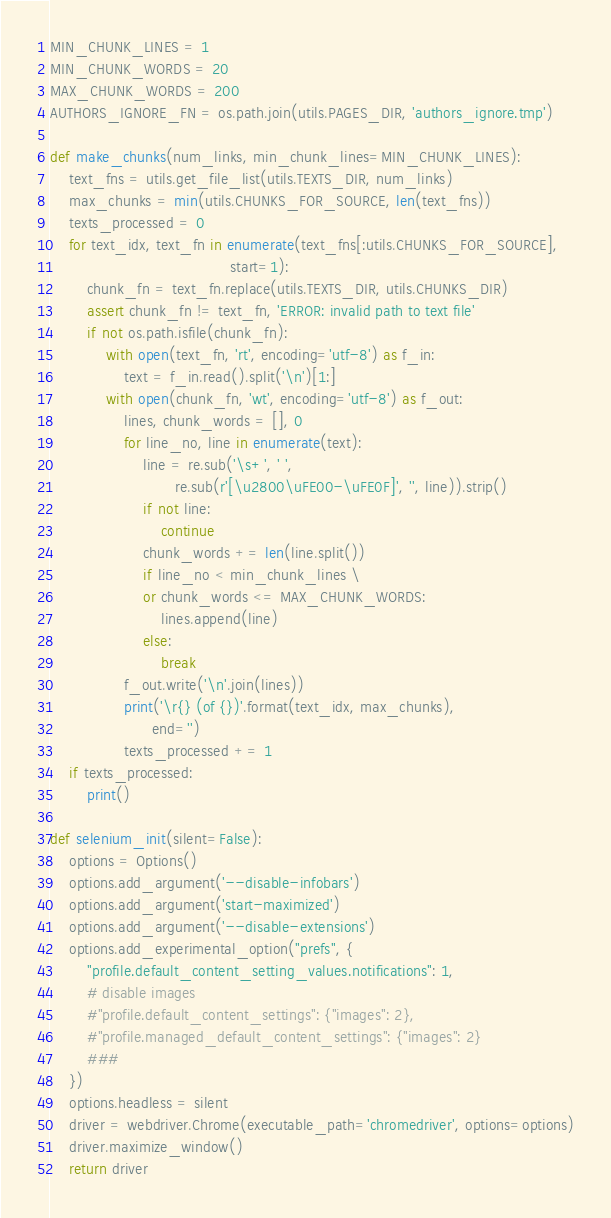<code> <loc_0><loc_0><loc_500><loc_500><_Python_>MIN_CHUNK_LINES = 1
MIN_CHUNK_WORDS = 20
MAX_CHUNK_WORDS = 200
AUTHORS_IGNORE_FN = os.path.join(utils.PAGES_DIR, 'authors_ignore.tmp')

def make_chunks(num_links, min_chunk_lines=MIN_CHUNK_LINES):
    text_fns = utils.get_file_list(utils.TEXTS_DIR, num_links)
    max_chunks = min(utils.CHUNKS_FOR_SOURCE, len(text_fns))
    texts_processed = 0
    for text_idx, text_fn in enumerate(text_fns[:utils.CHUNKS_FOR_SOURCE],
                                       start=1):
        chunk_fn = text_fn.replace(utils.TEXTS_DIR, utils.CHUNKS_DIR)
        assert chunk_fn != text_fn, 'ERROR: invalid path to text file'
        if not os.path.isfile(chunk_fn):
            with open(text_fn, 'rt', encoding='utf-8') as f_in:
                text = f_in.read().split('\n')[1:]
            with open(chunk_fn, 'wt', encoding='utf-8') as f_out:
                lines, chunk_words = [], 0
                for line_no, line in enumerate(text):
                    line = re.sub('\s+', ' ',
                           re.sub(r'[\u2800\uFE00-\uFE0F]', '', line)).strip()
                    if not line:
                        continue
                    chunk_words += len(line.split())
                    if line_no < min_chunk_lines \
                    or chunk_words <= MAX_CHUNK_WORDS:
                        lines.append(line)
                    else:
                        break
                f_out.write('\n'.join(lines))
                print('\r{} (of {})'.format(text_idx, max_chunks),
                      end='')
                texts_processed += 1
    if texts_processed:
        print()

def selenium_init(silent=False):
    options = Options()
    options.add_argument('--disable-infobars')
    options.add_argument('start-maximized')
    options.add_argument('--disable-extensions')
    options.add_experimental_option("prefs", {
        "profile.default_content_setting_values.notifications": 1,
        # disable images
        #"profile.default_content_settings": {"images": 2},
        #"profile.managed_default_content_settings": {"images": 2}
        ###
    })
    options.headless = silent
    driver = webdriver.Chrome(executable_path='chromedriver', options=options)
    driver.maximize_window()
    return driver
</code> 